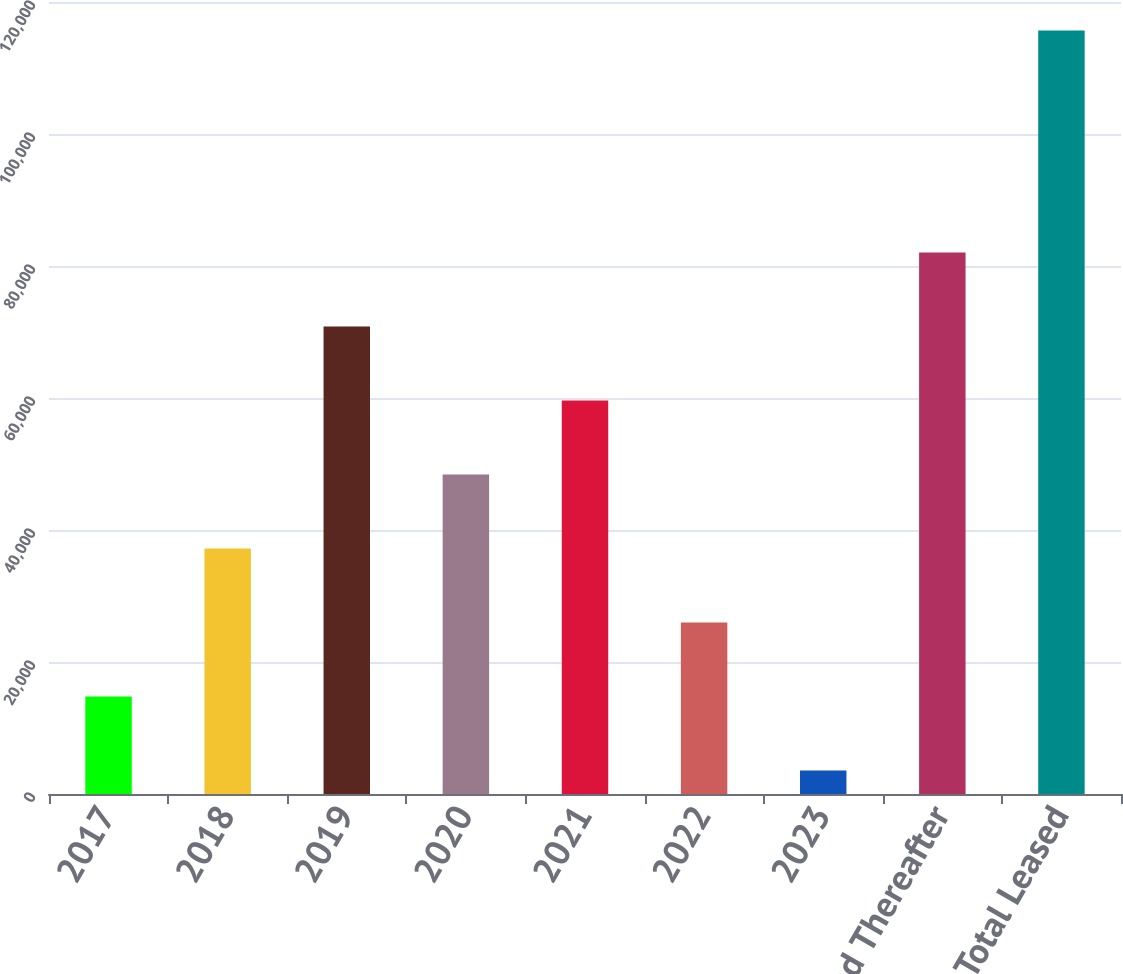Convert chart to OTSL. <chart><loc_0><loc_0><loc_500><loc_500><bar_chart><fcel>2017<fcel>2018<fcel>2019<fcel>2020<fcel>2021<fcel>2022<fcel>2023<fcel>2027 and Thereafter<fcel>Total Leased<nl><fcel>14767.9<fcel>37189.7<fcel>70822.4<fcel>48400.6<fcel>59611.5<fcel>25978.8<fcel>3557<fcel>82033.3<fcel>115666<nl></chart> 